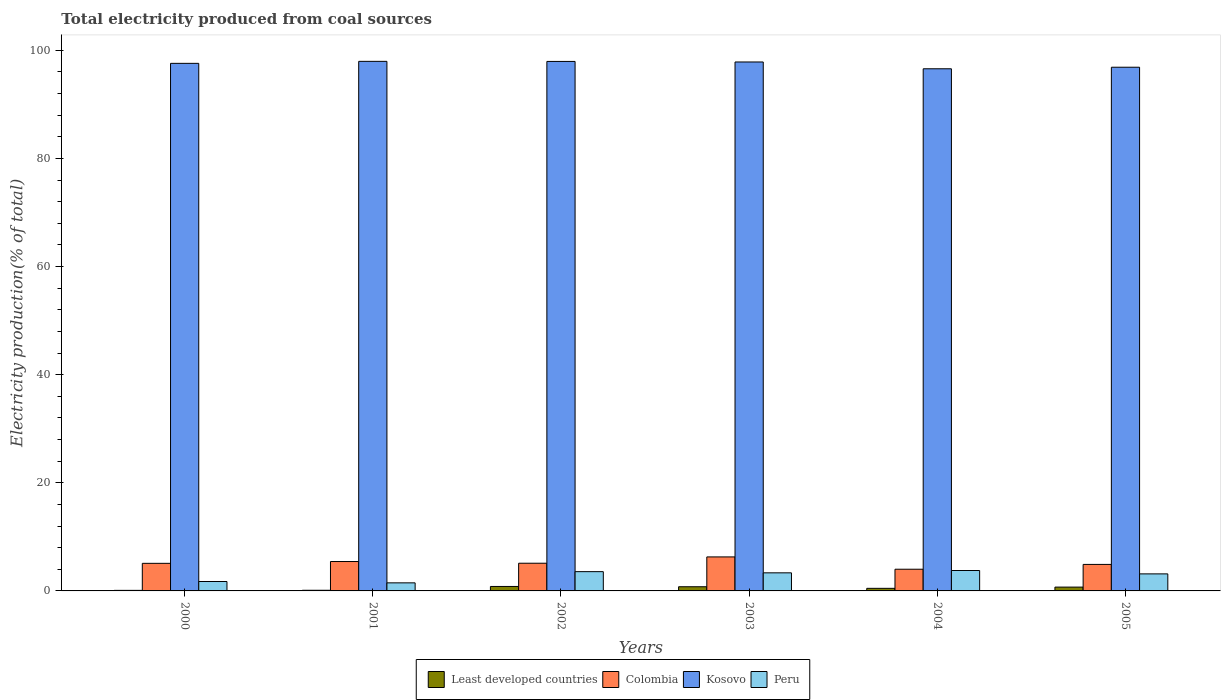Are the number of bars per tick equal to the number of legend labels?
Give a very brief answer. Yes. Are the number of bars on each tick of the X-axis equal?
Make the answer very short. Yes. How many bars are there on the 2nd tick from the left?
Ensure brevity in your answer.  4. How many bars are there on the 6th tick from the right?
Offer a very short reply. 4. In how many cases, is the number of bars for a given year not equal to the number of legend labels?
Provide a succinct answer. 0. What is the total electricity produced in Kosovo in 2004?
Provide a succinct answer. 96.59. Across all years, what is the maximum total electricity produced in Colombia?
Your answer should be very brief. 6.29. Across all years, what is the minimum total electricity produced in Peru?
Provide a short and direct response. 1.49. What is the total total electricity produced in Least developed countries in the graph?
Your answer should be very brief. 3.01. What is the difference between the total electricity produced in Kosovo in 2000 and that in 2002?
Your response must be concise. -0.36. What is the difference between the total electricity produced in Peru in 2000 and the total electricity produced in Colombia in 2001?
Your answer should be very brief. -3.69. What is the average total electricity produced in Kosovo per year?
Your answer should be compact. 97.47. In the year 2002, what is the difference between the total electricity produced in Kosovo and total electricity produced in Least developed countries?
Keep it short and to the point. 97.13. In how many years, is the total electricity produced in Colombia greater than 24 %?
Offer a terse response. 0. What is the ratio of the total electricity produced in Colombia in 2000 to that in 2001?
Keep it short and to the point. 0.94. Is the total electricity produced in Kosovo in 2003 less than that in 2005?
Offer a terse response. No. Is the difference between the total electricity produced in Kosovo in 2002 and 2003 greater than the difference between the total electricity produced in Least developed countries in 2002 and 2003?
Make the answer very short. Yes. What is the difference between the highest and the second highest total electricity produced in Least developed countries?
Your response must be concise. 0.05. What is the difference between the highest and the lowest total electricity produced in Kosovo?
Your answer should be compact. 1.37. In how many years, is the total electricity produced in Least developed countries greater than the average total electricity produced in Least developed countries taken over all years?
Offer a very short reply. 3. Is the sum of the total electricity produced in Least developed countries in 2004 and 2005 greater than the maximum total electricity produced in Kosovo across all years?
Your response must be concise. No. What does the 3rd bar from the left in 2000 represents?
Your response must be concise. Kosovo. What does the 4th bar from the right in 2005 represents?
Your answer should be compact. Least developed countries. How many bars are there?
Provide a succinct answer. 24. Are all the bars in the graph horizontal?
Keep it short and to the point. No. What is the difference between two consecutive major ticks on the Y-axis?
Your answer should be very brief. 20. Are the values on the major ticks of Y-axis written in scientific E-notation?
Make the answer very short. No. Does the graph contain any zero values?
Provide a succinct answer. No. Does the graph contain grids?
Provide a short and direct response. No. What is the title of the graph?
Your answer should be compact. Total electricity produced from coal sources. Does "Mauritania" appear as one of the legend labels in the graph?
Offer a terse response. No. What is the label or title of the X-axis?
Your answer should be compact. Years. What is the Electricity production(% of total) of Least developed countries in 2000?
Give a very brief answer. 0.1. What is the Electricity production(% of total) in Colombia in 2000?
Make the answer very short. 5.1. What is the Electricity production(% of total) in Kosovo in 2000?
Provide a short and direct response. 97.6. What is the Electricity production(% of total) in Peru in 2000?
Give a very brief answer. 1.74. What is the Electricity production(% of total) in Least developed countries in 2001?
Make the answer very short. 0.12. What is the Electricity production(% of total) in Colombia in 2001?
Provide a short and direct response. 5.44. What is the Electricity production(% of total) of Kosovo in 2001?
Your answer should be very brief. 97.97. What is the Electricity production(% of total) of Peru in 2001?
Keep it short and to the point. 1.49. What is the Electricity production(% of total) in Least developed countries in 2002?
Your response must be concise. 0.83. What is the Electricity production(% of total) in Colombia in 2002?
Keep it short and to the point. 5.12. What is the Electricity production(% of total) of Kosovo in 2002?
Make the answer very short. 97.95. What is the Electricity production(% of total) in Peru in 2002?
Provide a succinct answer. 3.57. What is the Electricity production(% of total) of Least developed countries in 2003?
Keep it short and to the point. 0.77. What is the Electricity production(% of total) of Colombia in 2003?
Your response must be concise. 6.29. What is the Electricity production(% of total) of Kosovo in 2003?
Your answer should be compact. 97.85. What is the Electricity production(% of total) in Peru in 2003?
Offer a terse response. 3.35. What is the Electricity production(% of total) of Least developed countries in 2004?
Your answer should be compact. 0.48. What is the Electricity production(% of total) of Colombia in 2004?
Give a very brief answer. 4.01. What is the Electricity production(% of total) of Kosovo in 2004?
Your answer should be compact. 96.59. What is the Electricity production(% of total) in Peru in 2004?
Keep it short and to the point. 3.78. What is the Electricity production(% of total) of Least developed countries in 2005?
Your response must be concise. 0.71. What is the Electricity production(% of total) of Colombia in 2005?
Provide a succinct answer. 4.9. What is the Electricity production(% of total) in Kosovo in 2005?
Keep it short and to the point. 96.88. What is the Electricity production(% of total) of Peru in 2005?
Your answer should be compact. 3.15. Across all years, what is the maximum Electricity production(% of total) in Least developed countries?
Your answer should be compact. 0.83. Across all years, what is the maximum Electricity production(% of total) of Colombia?
Ensure brevity in your answer.  6.29. Across all years, what is the maximum Electricity production(% of total) in Kosovo?
Give a very brief answer. 97.97. Across all years, what is the maximum Electricity production(% of total) in Peru?
Give a very brief answer. 3.78. Across all years, what is the minimum Electricity production(% of total) in Least developed countries?
Ensure brevity in your answer.  0.1. Across all years, what is the minimum Electricity production(% of total) of Colombia?
Keep it short and to the point. 4.01. Across all years, what is the minimum Electricity production(% of total) in Kosovo?
Offer a terse response. 96.59. Across all years, what is the minimum Electricity production(% of total) in Peru?
Your response must be concise. 1.49. What is the total Electricity production(% of total) in Least developed countries in the graph?
Offer a very short reply. 3.01. What is the total Electricity production(% of total) in Colombia in the graph?
Keep it short and to the point. 30.88. What is the total Electricity production(% of total) in Kosovo in the graph?
Provide a succinct answer. 584.85. What is the total Electricity production(% of total) in Peru in the graph?
Keep it short and to the point. 17.08. What is the difference between the Electricity production(% of total) in Least developed countries in 2000 and that in 2001?
Make the answer very short. -0.02. What is the difference between the Electricity production(% of total) of Colombia in 2000 and that in 2001?
Ensure brevity in your answer.  -0.33. What is the difference between the Electricity production(% of total) of Kosovo in 2000 and that in 2001?
Offer a very short reply. -0.37. What is the difference between the Electricity production(% of total) in Peru in 2000 and that in 2001?
Your answer should be compact. 0.25. What is the difference between the Electricity production(% of total) of Least developed countries in 2000 and that in 2002?
Your response must be concise. -0.72. What is the difference between the Electricity production(% of total) in Colombia in 2000 and that in 2002?
Offer a very short reply. -0.02. What is the difference between the Electricity production(% of total) in Kosovo in 2000 and that in 2002?
Give a very brief answer. -0.36. What is the difference between the Electricity production(% of total) in Peru in 2000 and that in 2002?
Make the answer very short. -1.82. What is the difference between the Electricity production(% of total) of Least developed countries in 2000 and that in 2003?
Your answer should be compact. -0.67. What is the difference between the Electricity production(% of total) in Colombia in 2000 and that in 2003?
Your answer should be very brief. -1.19. What is the difference between the Electricity production(% of total) of Kosovo in 2000 and that in 2003?
Keep it short and to the point. -0.25. What is the difference between the Electricity production(% of total) in Peru in 2000 and that in 2003?
Provide a short and direct response. -1.6. What is the difference between the Electricity production(% of total) in Least developed countries in 2000 and that in 2004?
Give a very brief answer. -0.38. What is the difference between the Electricity production(% of total) of Colombia in 2000 and that in 2004?
Your response must be concise. 1.09. What is the difference between the Electricity production(% of total) of Kosovo in 2000 and that in 2004?
Ensure brevity in your answer.  1. What is the difference between the Electricity production(% of total) in Peru in 2000 and that in 2004?
Keep it short and to the point. -2.03. What is the difference between the Electricity production(% of total) of Least developed countries in 2000 and that in 2005?
Your answer should be very brief. -0.61. What is the difference between the Electricity production(% of total) of Colombia in 2000 and that in 2005?
Provide a succinct answer. 0.2. What is the difference between the Electricity production(% of total) in Kosovo in 2000 and that in 2005?
Your response must be concise. 0.72. What is the difference between the Electricity production(% of total) of Peru in 2000 and that in 2005?
Provide a short and direct response. -1.41. What is the difference between the Electricity production(% of total) of Least developed countries in 2001 and that in 2002?
Provide a succinct answer. -0.71. What is the difference between the Electricity production(% of total) of Colombia in 2001 and that in 2002?
Give a very brief answer. 0.31. What is the difference between the Electricity production(% of total) in Kosovo in 2001 and that in 2002?
Give a very brief answer. 0.01. What is the difference between the Electricity production(% of total) in Peru in 2001 and that in 2002?
Offer a very short reply. -2.07. What is the difference between the Electricity production(% of total) of Least developed countries in 2001 and that in 2003?
Your answer should be very brief. -0.65. What is the difference between the Electricity production(% of total) of Colombia in 2001 and that in 2003?
Ensure brevity in your answer.  -0.85. What is the difference between the Electricity production(% of total) of Kosovo in 2001 and that in 2003?
Your answer should be compact. 0.12. What is the difference between the Electricity production(% of total) of Peru in 2001 and that in 2003?
Make the answer very short. -1.85. What is the difference between the Electricity production(% of total) of Least developed countries in 2001 and that in 2004?
Ensure brevity in your answer.  -0.36. What is the difference between the Electricity production(% of total) in Colombia in 2001 and that in 2004?
Provide a succinct answer. 1.42. What is the difference between the Electricity production(% of total) of Kosovo in 2001 and that in 2004?
Ensure brevity in your answer.  1.37. What is the difference between the Electricity production(% of total) in Peru in 2001 and that in 2004?
Your response must be concise. -2.28. What is the difference between the Electricity production(% of total) of Least developed countries in 2001 and that in 2005?
Make the answer very short. -0.59. What is the difference between the Electricity production(% of total) of Colombia in 2001 and that in 2005?
Provide a short and direct response. 0.53. What is the difference between the Electricity production(% of total) of Kosovo in 2001 and that in 2005?
Offer a very short reply. 1.09. What is the difference between the Electricity production(% of total) in Peru in 2001 and that in 2005?
Provide a succinct answer. -1.66. What is the difference between the Electricity production(% of total) in Least developed countries in 2002 and that in 2003?
Provide a succinct answer. 0.05. What is the difference between the Electricity production(% of total) in Colombia in 2002 and that in 2003?
Offer a terse response. -1.17. What is the difference between the Electricity production(% of total) of Kosovo in 2002 and that in 2003?
Keep it short and to the point. 0.1. What is the difference between the Electricity production(% of total) of Peru in 2002 and that in 2003?
Offer a very short reply. 0.22. What is the difference between the Electricity production(% of total) in Least developed countries in 2002 and that in 2004?
Keep it short and to the point. 0.35. What is the difference between the Electricity production(% of total) of Colombia in 2002 and that in 2004?
Give a very brief answer. 1.11. What is the difference between the Electricity production(% of total) in Kosovo in 2002 and that in 2004?
Offer a very short reply. 1.36. What is the difference between the Electricity production(% of total) of Peru in 2002 and that in 2004?
Provide a succinct answer. -0.21. What is the difference between the Electricity production(% of total) in Least developed countries in 2002 and that in 2005?
Your answer should be compact. 0.12. What is the difference between the Electricity production(% of total) in Colombia in 2002 and that in 2005?
Your answer should be very brief. 0.22. What is the difference between the Electricity production(% of total) of Kosovo in 2002 and that in 2005?
Offer a terse response. 1.07. What is the difference between the Electricity production(% of total) in Peru in 2002 and that in 2005?
Offer a very short reply. 0.41. What is the difference between the Electricity production(% of total) of Least developed countries in 2003 and that in 2004?
Keep it short and to the point. 0.3. What is the difference between the Electricity production(% of total) in Colombia in 2003 and that in 2004?
Give a very brief answer. 2.28. What is the difference between the Electricity production(% of total) in Kosovo in 2003 and that in 2004?
Offer a terse response. 1.26. What is the difference between the Electricity production(% of total) in Peru in 2003 and that in 2004?
Give a very brief answer. -0.43. What is the difference between the Electricity production(% of total) in Least developed countries in 2003 and that in 2005?
Provide a succinct answer. 0.07. What is the difference between the Electricity production(% of total) in Colombia in 2003 and that in 2005?
Give a very brief answer. 1.39. What is the difference between the Electricity production(% of total) in Kosovo in 2003 and that in 2005?
Keep it short and to the point. 0.97. What is the difference between the Electricity production(% of total) of Peru in 2003 and that in 2005?
Your answer should be compact. 0.19. What is the difference between the Electricity production(% of total) in Least developed countries in 2004 and that in 2005?
Keep it short and to the point. -0.23. What is the difference between the Electricity production(% of total) in Colombia in 2004 and that in 2005?
Your answer should be very brief. -0.89. What is the difference between the Electricity production(% of total) of Kosovo in 2004 and that in 2005?
Offer a terse response. -0.29. What is the difference between the Electricity production(% of total) in Peru in 2004 and that in 2005?
Give a very brief answer. 0.62. What is the difference between the Electricity production(% of total) in Least developed countries in 2000 and the Electricity production(% of total) in Colombia in 2001?
Your answer should be compact. -5.34. What is the difference between the Electricity production(% of total) of Least developed countries in 2000 and the Electricity production(% of total) of Kosovo in 2001?
Offer a very short reply. -97.87. What is the difference between the Electricity production(% of total) of Least developed countries in 2000 and the Electricity production(% of total) of Peru in 2001?
Keep it short and to the point. -1.39. What is the difference between the Electricity production(% of total) of Colombia in 2000 and the Electricity production(% of total) of Kosovo in 2001?
Your answer should be compact. -92.86. What is the difference between the Electricity production(% of total) in Colombia in 2000 and the Electricity production(% of total) in Peru in 2001?
Your response must be concise. 3.61. What is the difference between the Electricity production(% of total) in Kosovo in 2000 and the Electricity production(% of total) in Peru in 2001?
Your answer should be compact. 96.11. What is the difference between the Electricity production(% of total) of Least developed countries in 2000 and the Electricity production(% of total) of Colombia in 2002?
Your answer should be compact. -5.02. What is the difference between the Electricity production(% of total) in Least developed countries in 2000 and the Electricity production(% of total) in Kosovo in 2002?
Offer a very short reply. -97.85. What is the difference between the Electricity production(% of total) in Least developed countries in 2000 and the Electricity production(% of total) in Peru in 2002?
Keep it short and to the point. -3.46. What is the difference between the Electricity production(% of total) of Colombia in 2000 and the Electricity production(% of total) of Kosovo in 2002?
Ensure brevity in your answer.  -92.85. What is the difference between the Electricity production(% of total) of Colombia in 2000 and the Electricity production(% of total) of Peru in 2002?
Provide a succinct answer. 1.54. What is the difference between the Electricity production(% of total) of Kosovo in 2000 and the Electricity production(% of total) of Peru in 2002?
Provide a short and direct response. 94.03. What is the difference between the Electricity production(% of total) of Least developed countries in 2000 and the Electricity production(% of total) of Colombia in 2003?
Your answer should be very brief. -6.19. What is the difference between the Electricity production(% of total) of Least developed countries in 2000 and the Electricity production(% of total) of Kosovo in 2003?
Make the answer very short. -97.75. What is the difference between the Electricity production(% of total) of Least developed countries in 2000 and the Electricity production(% of total) of Peru in 2003?
Make the answer very short. -3.24. What is the difference between the Electricity production(% of total) in Colombia in 2000 and the Electricity production(% of total) in Kosovo in 2003?
Your response must be concise. -92.75. What is the difference between the Electricity production(% of total) in Colombia in 2000 and the Electricity production(% of total) in Peru in 2003?
Your answer should be compact. 1.76. What is the difference between the Electricity production(% of total) in Kosovo in 2000 and the Electricity production(% of total) in Peru in 2003?
Keep it short and to the point. 94.25. What is the difference between the Electricity production(% of total) of Least developed countries in 2000 and the Electricity production(% of total) of Colombia in 2004?
Your answer should be very brief. -3.91. What is the difference between the Electricity production(% of total) in Least developed countries in 2000 and the Electricity production(% of total) in Kosovo in 2004?
Your response must be concise. -96.49. What is the difference between the Electricity production(% of total) of Least developed countries in 2000 and the Electricity production(% of total) of Peru in 2004?
Make the answer very short. -3.67. What is the difference between the Electricity production(% of total) of Colombia in 2000 and the Electricity production(% of total) of Kosovo in 2004?
Your response must be concise. -91.49. What is the difference between the Electricity production(% of total) in Colombia in 2000 and the Electricity production(% of total) in Peru in 2004?
Your answer should be very brief. 1.33. What is the difference between the Electricity production(% of total) of Kosovo in 2000 and the Electricity production(% of total) of Peru in 2004?
Provide a short and direct response. 93.82. What is the difference between the Electricity production(% of total) of Least developed countries in 2000 and the Electricity production(% of total) of Colombia in 2005?
Offer a very short reply. -4.8. What is the difference between the Electricity production(% of total) of Least developed countries in 2000 and the Electricity production(% of total) of Kosovo in 2005?
Make the answer very short. -96.78. What is the difference between the Electricity production(% of total) in Least developed countries in 2000 and the Electricity production(% of total) in Peru in 2005?
Your answer should be compact. -3.05. What is the difference between the Electricity production(% of total) of Colombia in 2000 and the Electricity production(% of total) of Kosovo in 2005?
Your answer should be compact. -91.78. What is the difference between the Electricity production(% of total) of Colombia in 2000 and the Electricity production(% of total) of Peru in 2005?
Ensure brevity in your answer.  1.95. What is the difference between the Electricity production(% of total) of Kosovo in 2000 and the Electricity production(% of total) of Peru in 2005?
Ensure brevity in your answer.  94.45. What is the difference between the Electricity production(% of total) of Least developed countries in 2001 and the Electricity production(% of total) of Colombia in 2002?
Offer a very short reply. -5. What is the difference between the Electricity production(% of total) in Least developed countries in 2001 and the Electricity production(% of total) in Kosovo in 2002?
Provide a short and direct response. -97.83. What is the difference between the Electricity production(% of total) of Least developed countries in 2001 and the Electricity production(% of total) of Peru in 2002?
Keep it short and to the point. -3.45. What is the difference between the Electricity production(% of total) of Colombia in 2001 and the Electricity production(% of total) of Kosovo in 2002?
Your answer should be compact. -92.52. What is the difference between the Electricity production(% of total) of Colombia in 2001 and the Electricity production(% of total) of Peru in 2002?
Offer a terse response. 1.87. What is the difference between the Electricity production(% of total) of Kosovo in 2001 and the Electricity production(% of total) of Peru in 2002?
Make the answer very short. 94.4. What is the difference between the Electricity production(% of total) of Least developed countries in 2001 and the Electricity production(% of total) of Colombia in 2003?
Offer a very short reply. -6.17. What is the difference between the Electricity production(% of total) of Least developed countries in 2001 and the Electricity production(% of total) of Kosovo in 2003?
Keep it short and to the point. -97.73. What is the difference between the Electricity production(% of total) in Least developed countries in 2001 and the Electricity production(% of total) in Peru in 2003?
Keep it short and to the point. -3.22. What is the difference between the Electricity production(% of total) of Colombia in 2001 and the Electricity production(% of total) of Kosovo in 2003?
Make the answer very short. -92.41. What is the difference between the Electricity production(% of total) of Colombia in 2001 and the Electricity production(% of total) of Peru in 2003?
Offer a terse response. 2.09. What is the difference between the Electricity production(% of total) of Kosovo in 2001 and the Electricity production(% of total) of Peru in 2003?
Offer a very short reply. 94.62. What is the difference between the Electricity production(% of total) in Least developed countries in 2001 and the Electricity production(% of total) in Colombia in 2004?
Provide a short and direct response. -3.89. What is the difference between the Electricity production(% of total) in Least developed countries in 2001 and the Electricity production(% of total) in Kosovo in 2004?
Provide a succinct answer. -96.47. What is the difference between the Electricity production(% of total) in Least developed countries in 2001 and the Electricity production(% of total) in Peru in 2004?
Give a very brief answer. -3.66. What is the difference between the Electricity production(% of total) in Colombia in 2001 and the Electricity production(% of total) in Kosovo in 2004?
Offer a terse response. -91.16. What is the difference between the Electricity production(% of total) in Colombia in 2001 and the Electricity production(% of total) in Peru in 2004?
Ensure brevity in your answer.  1.66. What is the difference between the Electricity production(% of total) of Kosovo in 2001 and the Electricity production(% of total) of Peru in 2004?
Make the answer very short. 94.19. What is the difference between the Electricity production(% of total) of Least developed countries in 2001 and the Electricity production(% of total) of Colombia in 2005?
Provide a succinct answer. -4.78. What is the difference between the Electricity production(% of total) in Least developed countries in 2001 and the Electricity production(% of total) in Kosovo in 2005?
Provide a short and direct response. -96.76. What is the difference between the Electricity production(% of total) of Least developed countries in 2001 and the Electricity production(% of total) of Peru in 2005?
Keep it short and to the point. -3.03. What is the difference between the Electricity production(% of total) in Colombia in 2001 and the Electricity production(% of total) in Kosovo in 2005?
Your answer should be very brief. -91.44. What is the difference between the Electricity production(% of total) of Colombia in 2001 and the Electricity production(% of total) of Peru in 2005?
Make the answer very short. 2.28. What is the difference between the Electricity production(% of total) of Kosovo in 2001 and the Electricity production(% of total) of Peru in 2005?
Make the answer very short. 94.81. What is the difference between the Electricity production(% of total) of Least developed countries in 2002 and the Electricity production(% of total) of Colombia in 2003?
Make the answer very short. -5.47. What is the difference between the Electricity production(% of total) in Least developed countries in 2002 and the Electricity production(% of total) in Kosovo in 2003?
Your response must be concise. -97.03. What is the difference between the Electricity production(% of total) in Least developed countries in 2002 and the Electricity production(% of total) in Peru in 2003?
Offer a very short reply. -2.52. What is the difference between the Electricity production(% of total) in Colombia in 2002 and the Electricity production(% of total) in Kosovo in 2003?
Make the answer very short. -92.73. What is the difference between the Electricity production(% of total) of Colombia in 2002 and the Electricity production(% of total) of Peru in 2003?
Make the answer very short. 1.78. What is the difference between the Electricity production(% of total) in Kosovo in 2002 and the Electricity production(% of total) in Peru in 2003?
Give a very brief answer. 94.61. What is the difference between the Electricity production(% of total) in Least developed countries in 2002 and the Electricity production(% of total) in Colombia in 2004?
Give a very brief answer. -3.19. What is the difference between the Electricity production(% of total) of Least developed countries in 2002 and the Electricity production(% of total) of Kosovo in 2004?
Your answer should be compact. -95.77. What is the difference between the Electricity production(% of total) in Least developed countries in 2002 and the Electricity production(% of total) in Peru in 2004?
Offer a terse response. -2.95. What is the difference between the Electricity production(% of total) in Colombia in 2002 and the Electricity production(% of total) in Kosovo in 2004?
Offer a terse response. -91.47. What is the difference between the Electricity production(% of total) of Colombia in 2002 and the Electricity production(% of total) of Peru in 2004?
Ensure brevity in your answer.  1.35. What is the difference between the Electricity production(% of total) of Kosovo in 2002 and the Electricity production(% of total) of Peru in 2004?
Give a very brief answer. 94.18. What is the difference between the Electricity production(% of total) in Least developed countries in 2002 and the Electricity production(% of total) in Colombia in 2005?
Offer a very short reply. -4.08. What is the difference between the Electricity production(% of total) in Least developed countries in 2002 and the Electricity production(% of total) in Kosovo in 2005?
Offer a very short reply. -96.06. What is the difference between the Electricity production(% of total) in Least developed countries in 2002 and the Electricity production(% of total) in Peru in 2005?
Keep it short and to the point. -2.33. What is the difference between the Electricity production(% of total) of Colombia in 2002 and the Electricity production(% of total) of Kosovo in 2005?
Your answer should be very brief. -91.76. What is the difference between the Electricity production(% of total) of Colombia in 2002 and the Electricity production(% of total) of Peru in 2005?
Your response must be concise. 1.97. What is the difference between the Electricity production(% of total) in Kosovo in 2002 and the Electricity production(% of total) in Peru in 2005?
Keep it short and to the point. 94.8. What is the difference between the Electricity production(% of total) of Least developed countries in 2003 and the Electricity production(% of total) of Colombia in 2004?
Provide a short and direct response. -3.24. What is the difference between the Electricity production(% of total) in Least developed countries in 2003 and the Electricity production(% of total) in Kosovo in 2004?
Provide a succinct answer. -95.82. What is the difference between the Electricity production(% of total) in Least developed countries in 2003 and the Electricity production(% of total) in Peru in 2004?
Make the answer very short. -3. What is the difference between the Electricity production(% of total) of Colombia in 2003 and the Electricity production(% of total) of Kosovo in 2004?
Provide a short and direct response. -90.3. What is the difference between the Electricity production(% of total) of Colombia in 2003 and the Electricity production(% of total) of Peru in 2004?
Keep it short and to the point. 2.51. What is the difference between the Electricity production(% of total) in Kosovo in 2003 and the Electricity production(% of total) in Peru in 2004?
Your response must be concise. 94.07. What is the difference between the Electricity production(% of total) in Least developed countries in 2003 and the Electricity production(% of total) in Colombia in 2005?
Offer a terse response. -4.13. What is the difference between the Electricity production(% of total) of Least developed countries in 2003 and the Electricity production(% of total) of Kosovo in 2005?
Ensure brevity in your answer.  -96.11. What is the difference between the Electricity production(% of total) in Least developed countries in 2003 and the Electricity production(% of total) in Peru in 2005?
Provide a short and direct response. -2.38. What is the difference between the Electricity production(% of total) in Colombia in 2003 and the Electricity production(% of total) in Kosovo in 2005?
Provide a succinct answer. -90.59. What is the difference between the Electricity production(% of total) of Colombia in 2003 and the Electricity production(% of total) of Peru in 2005?
Give a very brief answer. 3.14. What is the difference between the Electricity production(% of total) of Kosovo in 2003 and the Electricity production(% of total) of Peru in 2005?
Provide a succinct answer. 94.7. What is the difference between the Electricity production(% of total) in Least developed countries in 2004 and the Electricity production(% of total) in Colombia in 2005?
Offer a terse response. -4.43. What is the difference between the Electricity production(% of total) of Least developed countries in 2004 and the Electricity production(% of total) of Kosovo in 2005?
Ensure brevity in your answer.  -96.4. What is the difference between the Electricity production(% of total) in Least developed countries in 2004 and the Electricity production(% of total) in Peru in 2005?
Provide a succinct answer. -2.68. What is the difference between the Electricity production(% of total) in Colombia in 2004 and the Electricity production(% of total) in Kosovo in 2005?
Offer a terse response. -92.87. What is the difference between the Electricity production(% of total) of Colombia in 2004 and the Electricity production(% of total) of Peru in 2005?
Your answer should be compact. 0.86. What is the difference between the Electricity production(% of total) in Kosovo in 2004 and the Electricity production(% of total) in Peru in 2005?
Your response must be concise. 93.44. What is the average Electricity production(% of total) in Least developed countries per year?
Make the answer very short. 0.5. What is the average Electricity production(% of total) in Colombia per year?
Ensure brevity in your answer.  5.15. What is the average Electricity production(% of total) in Kosovo per year?
Ensure brevity in your answer.  97.47. What is the average Electricity production(% of total) of Peru per year?
Make the answer very short. 2.85. In the year 2000, what is the difference between the Electricity production(% of total) in Least developed countries and Electricity production(% of total) in Colombia?
Provide a succinct answer. -5. In the year 2000, what is the difference between the Electricity production(% of total) in Least developed countries and Electricity production(% of total) in Kosovo?
Provide a succinct answer. -97.5. In the year 2000, what is the difference between the Electricity production(% of total) of Least developed countries and Electricity production(% of total) of Peru?
Provide a short and direct response. -1.64. In the year 2000, what is the difference between the Electricity production(% of total) of Colombia and Electricity production(% of total) of Kosovo?
Make the answer very short. -92.5. In the year 2000, what is the difference between the Electricity production(% of total) of Colombia and Electricity production(% of total) of Peru?
Keep it short and to the point. 3.36. In the year 2000, what is the difference between the Electricity production(% of total) of Kosovo and Electricity production(% of total) of Peru?
Your answer should be compact. 95.86. In the year 2001, what is the difference between the Electricity production(% of total) of Least developed countries and Electricity production(% of total) of Colombia?
Offer a very short reply. -5.32. In the year 2001, what is the difference between the Electricity production(% of total) of Least developed countries and Electricity production(% of total) of Kosovo?
Offer a very short reply. -97.85. In the year 2001, what is the difference between the Electricity production(% of total) of Least developed countries and Electricity production(% of total) of Peru?
Provide a succinct answer. -1.37. In the year 2001, what is the difference between the Electricity production(% of total) of Colombia and Electricity production(% of total) of Kosovo?
Make the answer very short. -92.53. In the year 2001, what is the difference between the Electricity production(% of total) of Colombia and Electricity production(% of total) of Peru?
Your answer should be compact. 3.95. In the year 2001, what is the difference between the Electricity production(% of total) of Kosovo and Electricity production(% of total) of Peru?
Make the answer very short. 96.48. In the year 2002, what is the difference between the Electricity production(% of total) of Least developed countries and Electricity production(% of total) of Colombia?
Make the answer very short. -4.3. In the year 2002, what is the difference between the Electricity production(% of total) of Least developed countries and Electricity production(% of total) of Kosovo?
Your response must be concise. -97.13. In the year 2002, what is the difference between the Electricity production(% of total) of Least developed countries and Electricity production(% of total) of Peru?
Give a very brief answer. -2.74. In the year 2002, what is the difference between the Electricity production(% of total) in Colombia and Electricity production(% of total) in Kosovo?
Your response must be concise. -92.83. In the year 2002, what is the difference between the Electricity production(% of total) in Colombia and Electricity production(% of total) in Peru?
Your answer should be very brief. 1.56. In the year 2002, what is the difference between the Electricity production(% of total) of Kosovo and Electricity production(% of total) of Peru?
Your answer should be very brief. 94.39. In the year 2003, what is the difference between the Electricity production(% of total) in Least developed countries and Electricity production(% of total) in Colombia?
Your answer should be very brief. -5.52. In the year 2003, what is the difference between the Electricity production(% of total) of Least developed countries and Electricity production(% of total) of Kosovo?
Offer a very short reply. -97.08. In the year 2003, what is the difference between the Electricity production(% of total) of Least developed countries and Electricity production(% of total) of Peru?
Give a very brief answer. -2.57. In the year 2003, what is the difference between the Electricity production(% of total) of Colombia and Electricity production(% of total) of Kosovo?
Your answer should be very brief. -91.56. In the year 2003, what is the difference between the Electricity production(% of total) in Colombia and Electricity production(% of total) in Peru?
Give a very brief answer. 2.95. In the year 2003, what is the difference between the Electricity production(% of total) of Kosovo and Electricity production(% of total) of Peru?
Keep it short and to the point. 94.51. In the year 2004, what is the difference between the Electricity production(% of total) in Least developed countries and Electricity production(% of total) in Colombia?
Keep it short and to the point. -3.54. In the year 2004, what is the difference between the Electricity production(% of total) of Least developed countries and Electricity production(% of total) of Kosovo?
Your answer should be compact. -96.12. In the year 2004, what is the difference between the Electricity production(% of total) in Least developed countries and Electricity production(% of total) in Peru?
Keep it short and to the point. -3.3. In the year 2004, what is the difference between the Electricity production(% of total) of Colombia and Electricity production(% of total) of Kosovo?
Keep it short and to the point. -92.58. In the year 2004, what is the difference between the Electricity production(% of total) of Colombia and Electricity production(% of total) of Peru?
Offer a terse response. 0.24. In the year 2004, what is the difference between the Electricity production(% of total) in Kosovo and Electricity production(% of total) in Peru?
Offer a very short reply. 92.82. In the year 2005, what is the difference between the Electricity production(% of total) of Least developed countries and Electricity production(% of total) of Colombia?
Provide a succinct answer. -4.2. In the year 2005, what is the difference between the Electricity production(% of total) of Least developed countries and Electricity production(% of total) of Kosovo?
Your answer should be compact. -96.17. In the year 2005, what is the difference between the Electricity production(% of total) in Least developed countries and Electricity production(% of total) in Peru?
Your answer should be very brief. -2.45. In the year 2005, what is the difference between the Electricity production(% of total) in Colombia and Electricity production(% of total) in Kosovo?
Offer a very short reply. -91.98. In the year 2005, what is the difference between the Electricity production(% of total) of Colombia and Electricity production(% of total) of Peru?
Your answer should be very brief. 1.75. In the year 2005, what is the difference between the Electricity production(% of total) of Kosovo and Electricity production(% of total) of Peru?
Give a very brief answer. 93.73. What is the ratio of the Electricity production(% of total) of Least developed countries in 2000 to that in 2001?
Provide a short and direct response. 0.84. What is the ratio of the Electricity production(% of total) in Colombia in 2000 to that in 2001?
Provide a succinct answer. 0.94. What is the ratio of the Electricity production(% of total) of Kosovo in 2000 to that in 2001?
Your answer should be very brief. 1. What is the ratio of the Electricity production(% of total) of Peru in 2000 to that in 2001?
Give a very brief answer. 1.17. What is the ratio of the Electricity production(% of total) of Least developed countries in 2000 to that in 2002?
Provide a short and direct response. 0.12. What is the ratio of the Electricity production(% of total) in Colombia in 2000 to that in 2002?
Your response must be concise. 1. What is the ratio of the Electricity production(% of total) of Kosovo in 2000 to that in 2002?
Your answer should be compact. 1. What is the ratio of the Electricity production(% of total) of Peru in 2000 to that in 2002?
Offer a terse response. 0.49. What is the ratio of the Electricity production(% of total) of Least developed countries in 2000 to that in 2003?
Your response must be concise. 0.13. What is the ratio of the Electricity production(% of total) of Colombia in 2000 to that in 2003?
Offer a terse response. 0.81. What is the ratio of the Electricity production(% of total) in Kosovo in 2000 to that in 2003?
Your response must be concise. 1. What is the ratio of the Electricity production(% of total) in Peru in 2000 to that in 2003?
Your response must be concise. 0.52. What is the ratio of the Electricity production(% of total) in Least developed countries in 2000 to that in 2004?
Give a very brief answer. 0.21. What is the ratio of the Electricity production(% of total) of Colombia in 2000 to that in 2004?
Offer a terse response. 1.27. What is the ratio of the Electricity production(% of total) in Kosovo in 2000 to that in 2004?
Your answer should be very brief. 1.01. What is the ratio of the Electricity production(% of total) of Peru in 2000 to that in 2004?
Ensure brevity in your answer.  0.46. What is the ratio of the Electricity production(% of total) in Least developed countries in 2000 to that in 2005?
Give a very brief answer. 0.14. What is the ratio of the Electricity production(% of total) of Colombia in 2000 to that in 2005?
Make the answer very short. 1.04. What is the ratio of the Electricity production(% of total) in Kosovo in 2000 to that in 2005?
Offer a very short reply. 1.01. What is the ratio of the Electricity production(% of total) in Peru in 2000 to that in 2005?
Provide a succinct answer. 0.55. What is the ratio of the Electricity production(% of total) of Least developed countries in 2001 to that in 2002?
Ensure brevity in your answer.  0.15. What is the ratio of the Electricity production(% of total) in Colombia in 2001 to that in 2002?
Provide a short and direct response. 1.06. What is the ratio of the Electricity production(% of total) of Kosovo in 2001 to that in 2002?
Offer a very short reply. 1. What is the ratio of the Electricity production(% of total) in Peru in 2001 to that in 2002?
Your response must be concise. 0.42. What is the ratio of the Electricity production(% of total) of Least developed countries in 2001 to that in 2003?
Provide a succinct answer. 0.16. What is the ratio of the Electricity production(% of total) in Colombia in 2001 to that in 2003?
Your answer should be compact. 0.86. What is the ratio of the Electricity production(% of total) of Kosovo in 2001 to that in 2003?
Provide a succinct answer. 1. What is the ratio of the Electricity production(% of total) of Peru in 2001 to that in 2003?
Your answer should be very brief. 0.45. What is the ratio of the Electricity production(% of total) in Least developed countries in 2001 to that in 2004?
Provide a short and direct response. 0.25. What is the ratio of the Electricity production(% of total) of Colombia in 2001 to that in 2004?
Offer a terse response. 1.35. What is the ratio of the Electricity production(% of total) of Kosovo in 2001 to that in 2004?
Keep it short and to the point. 1.01. What is the ratio of the Electricity production(% of total) of Peru in 2001 to that in 2004?
Offer a terse response. 0.4. What is the ratio of the Electricity production(% of total) in Least developed countries in 2001 to that in 2005?
Offer a terse response. 0.17. What is the ratio of the Electricity production(% of total) of Colombia in 2001 to that in 2005?
Keep it short and to the point. 1.11. What is the ratio of the Electricity production(% of total) of Kosovo in 2001 to that in 2005?
Provide a short and direct response. 1.01. What is the ratio of the Electricity production(% of total) of Peru in 2001 to that in 2005?
Offer a very short reply. 0.47. What is the ratio of the Electricity production(% of total) in Least developed countries in 2002 to that in 2003?
Keep it short and to the point. 1.07. What is the ratio of the Electricity production(% of total) of Colombia in 2002 to that in 2003?
Offer a terse response. 0.81. What is the ratio of the Electricity production(% of total) of Peru in 2002 to that in 2003?
Provide a succinct answer. 1.07. What is the ratio of the Electricity production(% of total) in Least developed countries in 2002 to that in 2004?
Your answer should be compact. 1.73. What is the ratio of the Electricity production(% of total) in Colombia in 2002 to that in 2004?
Provide a succinct answer. 1.28. What is the ratio of the Electricity production(% of total) of Kosovo in 2002 to that in 2004?
Ensure brevity in your answer.  1.01. What is the ratio of the Electricity production(% of total) in Peru in 2002 to that in 2004?
Your response must be concise. 0.94. What is the ratio of the Electricity production(% of total) in Least developed countries in 2002 to that in 2005?
Your response must be concise. 1.17. What is the ratio of the Electricity production(% of total) of Colombia in 2002 to that in 2005?
Your answer should be compact. 1.04. What is the ratio of the Electricity production(% of total) of Kosovo in 2002 to that in 2005?
Ensure brevity in your answer.  1.01. What is the ratio of the Electricity production(% of total) of Peru in 2002 to that in 2005?
Keep it short and to the point. 1.13. What is the ratio of the Electricity production(% of total) in Least developed countries in 2003 to that in 2004?
Keep it short and to the point. 1.62. What is the ratio of the Electricity production(% of total) of Colombia in 2003 to that in 2004?
Your answer should be very brief. 1.57. What is the ratio of the Electricity production(% of total) in Kosovo in 2003 to that in 2004?
Your response must be concise. 1.01. What is the ratio of the Electricity production(% of total) in Peru in 2003 to that in 2004?
Your answer should be compact. 0.89. What is the ratio of the Electricity production(% of total) in Least developed countries in 2003 to that in 2005?
Give a very brief answer. 1.09. What is the ratio of the Electricity production(% of total) in Colombia in 2003 to that in 2005?
Provide a succinct answer. 1.28. What is the ratio of the Electricity production(% of total) in Peru in 2003 to that in 2005?
Make the answer very short. 1.06. What is the ratio of the Electricity production(% of total) of Least developed countries in 2004 to that in 2005?
Your answer should be compact. 0.68. What is the ratio of the Electricity production(% of total) of Colombia in 2004 to that in 2005?
Offer a terse response. 0.82. What is the ratio of the Electricity production(% of total) of Peru in 2004 to that in 2005?
Make the answer very short. 1.2. What is the difference between the highest and the second highest Electricity production(% of total) in Least developed countries?
Make the answer very short. 0.05. What is the difference between the highest and the second highest Electricity production(% of total) in Colombia?
Your answer should be compact. 0.85. What is the difference between the highest and the second highest Electricity production(% of total) in Kosovo?
Keep it short and to the point. 0.01. What is the difference between the highest and the second highest Electricity production(% of total) in Peru?
Make the answer very short. 0.21. What is the difference between the highest and the lowest Electricity production(% of total) of Least developed countries?
Ensure brevity in your answer.  0.72. What is the difference between the highest and the lowest Electricity production(% of total) in Colombia?
Keep it short and to the point. 2.28. What is the difference between the highest and the lowest Electricity production(% of total) in Kosovo?
Offer a terse response. 1.37. What is the difference between the highest and the lowest Electricity production(% of total) in Peru?
Provide a short and direct response. 2.28. 